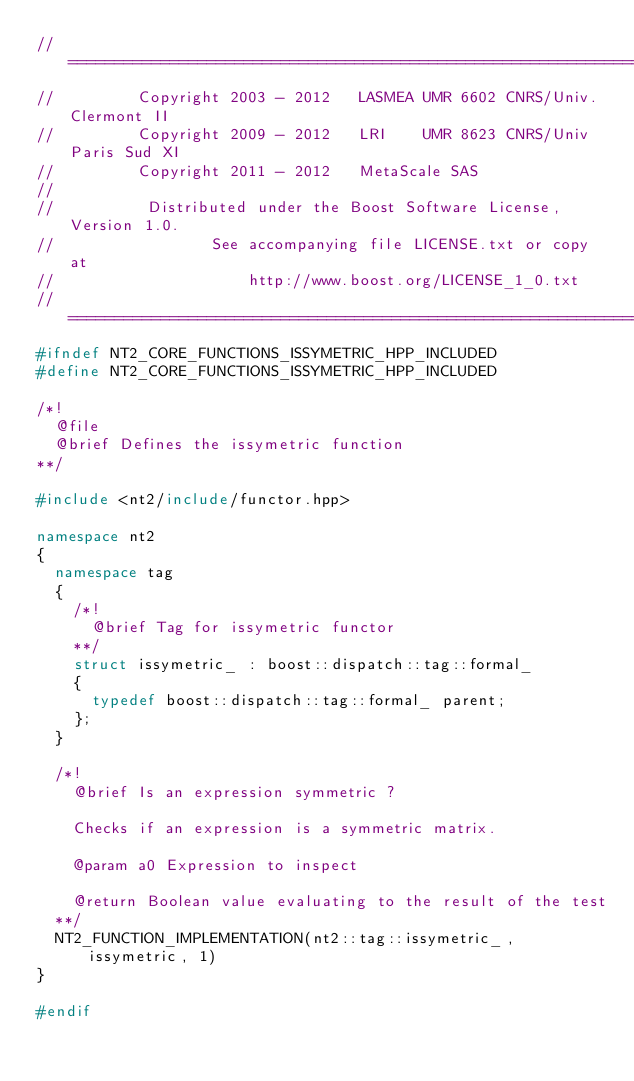<code> <loc_0><loc_0><loc_500><loc_500><_C++_>//==============================================================================
//         Copyright 2003 - 2012   LASMEA UMR 6602 CNRS/Univ. Clermont II
//         Copyright 2009 - 2012   LRI    UMR 8623 CNRS/Univ Paris Sud XI
//         Copyright 2011 - 2012   MetaScale SAS
//
//          Distributed under the Boost Software License, Version 1.0.
//                 See accompanying file LICENSE.txt or copy at
//                     http://www.boost.org/LICENSE_1_0.txt
//==============================================================================
#ifndef NT2_CORE_FUNCTIONS_ISSYMETRIC_HPP_INCLUDED
#define NT2_CORE_FUNCTIONS_ISSYMETRIC_HPP_INCLUDED

/*!
  @file
  @brief Defines the issymetric function
**/

#include <nt2/include/functor.hpp>

namespace nt2
{
  namespace tag
  {
    /*!
      @brief Tag for issymetric functor
    **/
    struct issymetric_ : boost::dispatch::tag::formal_
    {
      typedef boost::dispatch::tag::formal_ parent;
    };
  }

  /*!
    @brief Is an expression symmetric ?

    Checks if an expression is a symmetric matrix.

    @param a0 Expression to inspect

    @return Boolean value evaluating to the result of the test
  **/
  NT2_FUNCTION_IMPLEMENTATION(nt2::tag::issymetric_, issymetric, 1)
}

#endif

</code> 